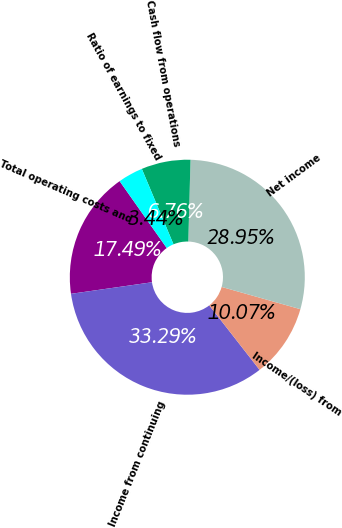<chart> <loc_0><loc_0><loc_500><loc_500><pie_chart><fcel>Total operating costs and<fcel>Income from continuing<fcel>Income/(loss) from<fcel>Net income<fcel>Cash flow from operations<fcel>Ratio of earnings to fixed<nl><fcel>17.49%<fcel>33.29%<fcel>10.07%<fcel>28.95%<fcel>6.76%<fcel>3.44%<nl></chart> 